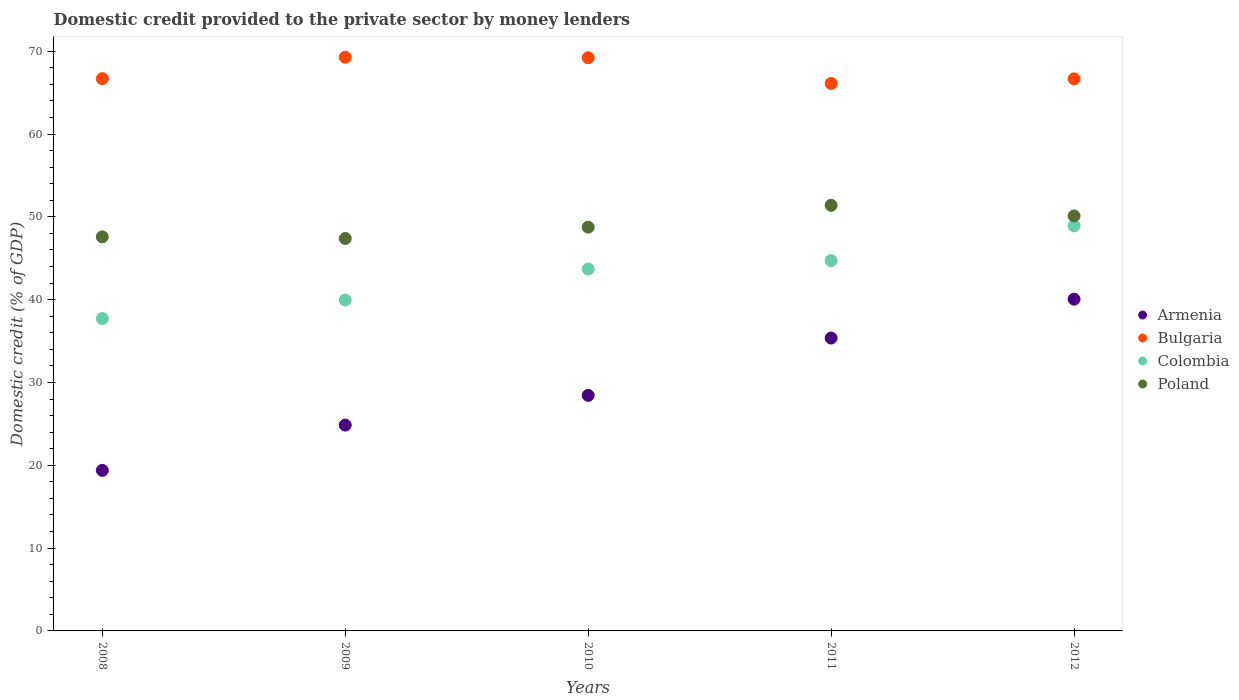How many different coloured dotlines are there?
Your response must be concise. 4. What is the domestic credit provided to the private sector by money lenders in Armenia in 2008?
Give a very brief answer. 19.39. Across all years, what is the maximum domestic credit provided to the private sector by money lenders in Bulgaria?
Your answer should be very brief. 69.28. Across all years, what is the minimum domestic credit provided to the private sector by money lenders in Colombia?
Ensure brevity in your answer.  37.72. What is the total domestic credit provided to the private sector by money lenders in Colombia in the graph?
Provide a succinct answer. 215.03. What is the difference between the domestic credit provided to the private sector by money lenders in Bulgaria in 2008 and that in 2010?
Keep it short and to the point. -2.53. What is the difference between the domestic credit provided to the private sector by money lenders in Poland in 2009 and the domestic credit provided to the private sector by money lenders in Armenia in 2010?
Provide a short and direct response. 18.95. What is the average domestic credit provided to the private sector by money lenders in Poland per year?
Ensure brevity in your answer.  49.05. In the year 2011, what is the difference between the domestic credit provided to the private sector by money lenders in Colombia and domestic credit provided to the private sector by money lenders in Bulgaria?
Keep it short and to the point. -21.4. In how many years, is the domestic credit provided to the private sector by money lenders in Poland greater than 42 %?
Make the answer very short. 5. What is the ratio of the domestic credit provided to the private sector by money lenders in Armenia in 2009 to that in 2011?
Keep it short and to the point. 0.7. Is the difference between the domestic credit provided to the private sector by money lenders in Colombia in 2010 and 2011 greater than the difference between the domestic credit provided to the private sector by money lenders in Bulgaria in 2010 and 2011?
Provide a short and direct response. No. What is the difference between the highest and the second highest domestic credit provided to the private sector by money lenders in Armenia?
Provide a short and direct response. 4.69. What is the difference between the highest and the lowest domestic credit provided to the private sector by money lenders in Poland?
Provide a succinct answer. 4.01. In how many years, is the domestic credit provided to the private sector by money lenders in Bulgaria greater than the average domestic credit provided to the private sector by money lenders in Bulgaria taken over all years?
Provide a short and direct response. 2. Is the domestic credit provided to the private sector by money lenders in Bulgaria strictly greater than the domestic credit provided to the private sector by money lenders in Armenia over the years?
Provide a short and direct response. Yes. Is the domestic credit provided to the private sector by money lenders in Poland strictly less than the domestic credit provided to the private sector by money lenders in Bulgaria over the years?
Your answer should be very brief. Yes. How many years are there in the graph?
Your answer should be very brief. 5. Are the values on the major ticks of Y-axis written in scientific E-notation?
Give a very brief answer. No. Does the graph contain any zero values?
Give a very brief answer. No. Where does the legend appear in the graph?
Make the answer very short. Center right. How are the legend labels stacked?
Your answer should be compact. Vertical. What is the title of the graph?
Provide a short and direct response. Domestic credit provided to the private sector by money lenders. Does "Turkey" appear as one of the legend labels in the graph?
Make the answer very short. No. What is the label or title of the X-axis?
Your response must be concise. Years. What is the label or title of the Y-axis?
Offer a very short reply. Domestic credit (% of GDP). What is the Domestic credit (% of GDP) in Armenia in 2008?
Your response must be concise. 19.39. What is the Domestic credit (% of GDP) in Bulgaria in 2008?
Your answer should be compact. 66.69. What is the Domestic credit (% of GDP) of Colombia in 2008?
Provide a succinct answer. 37.72. What is the Domestic credit (% of GDP) of Poland in 2008?
Offer a terse response. 47.59. What is the Domestic credit (% of GDP) in Armenia in 2009?
Make the answer very short. 24.85. What is the Domestic credit (% of GDP) in Bulgaria in 2009?
Keep it short and to the point. 69.28. What is the Domestic credit (% of GDP) in Colombia in 2009?
Your answer should be very brief. 39.96. What is the Domestic credit (% of GDP) in Poland in 2009?
Give a very brief answer. 47.39. What is the Domestic credit (% of GDP) of Armenia in 2010?
Your answer should be very brief. 28.45. What is the Domestic credit (% of GDP) in Bulgaria in 2010?
Ensure brevity in your answer.  69.23. What is the Domestic credit (% of GDP) of Colombia in 2010?
Offer a terse response. 43.7. What is the Domestic credit (% of GDP) in Poland in 2010?
Keep it short and to the point. 48.76. What is the Domestic credit (% of GDP) in Armenia in 2011?
Give a very brief answer. 35.37. What is the Domestic credit (% of GDP) of Bulgaria in 2011?
Ensure brevity in your answer.  66.12. What is the Domestic credit (% of GDP) of Colombia in 2011?
Your response must be concise. 44.72. What is the Domestic credit (% of GDP) in Poland in 2011?
Make the answer very short. 51.4. What is the Domestic credit (% of GDP) of Armenia in 2012?
Ensure brevity in your answer.  40.06. What is the Domestic credit (% of GDP) of Bulgaria in 2012?
Offer a terse response. 66.67. What is the Domestic credit (% of GDP) in Colombia in 2012?
Keep it short and to the point. 48.92. What is the Domestic credit (% of GDP) of Poland in 2012?
Your answer should be compact. 50.12. Across all years, what is the maximum Domestic credit (% of GDP) of Armenia?
Offer a terse response. 40.06. Across all years, what is the maximum Domestic credit (% of GDP) of Bulgaria?
Offer a terse response. 69.28. Across all years, what is the maximum Domestic credit (% of GDP) in Colombia?
Keep it short and to the point. 48.92. Across all years, what is the maximum Domestic credit (% of GDP) of Poland?
Offer a terse response. 51.4. Across all years, what is the minimum Domestic credit (% of GDP) in Armenia?
Your response must be concise. 19.39. Across all years, what is the minimum Domestic credit (% of GDP) in Bulgaria?
Ensure brevity in your answer.  66.12. Across all years, what is the minimum Domestic credit (% of GDP) in Colombia?
Offer a terse response. 37.72. Across all years, what is the minimum Domestic credit (% of GDP) of Poland?
Make the answer very short. 47.39. What is the total Domestic credit (% of GDP) of Armenia in the graph?
Ensure brevity in your answer.  148.11. What is the total Domestic credit (% of GDP) of Bulgaria in the graph?
Make the answer very short. 337.98. What is the total Domestic credit (% of GDP) in Colombia in the graph?
Provide a short and direct response. 215.03. What is the total Domestic credit (% of GDP) in Poland in the graph?
Provide a short and direct response. 245.25. What is the difference between the Domestic credit (% of GDP) in Armenia in 2008 and that in 2009?
Make the answer very short. -5.47. What is the difference between the Domestic credit (% of GDP) of Bulgaria in 2008 and that in 2009?
Make the answer very short. -2.58. What is the difference between the Domestic credit (% of GDP) of Colombia in 2008 and that in 2009?
Keep it short and to the point. -2.24. What is the difference between the Domestic credit (% of GDP) of Poland in 2008 and that in 2009?
Give a very brief answer. 0.2. What is the difference between the Domestic credit (% of GDP) in Armenia in 2008 and that in 2010?
Ensure brevity in your answer.  -9.06. What is the difference between the Domestic credit (% of GDP) in Bulgaria in 2008 and that in 2010?
Ensure brevity in your answer.  -2.53. What is the difference between the Domestic credit (% of GDP) of Colombia in 2008 and that in 2010?
Provide a succinct answer. -5.98. What is the difference between the Domestic credit (% of GDP) of Poland in 2008 and that in 2010?
Give a very brief answer. -1.17. What is the difference between the Domestic credit (% of GDP) of Armenia in 2008 and that in 2011?
Your answer should be very brief. -15.98. What is the difference between the Domestic credit (% of GDP) of Bulgaria in 2008 and that in 2011?
Make the answer very short. 0.58. What is the difference between the Domestic credit (% of GDP) in Colombia in 2008 and that in 2011?
Give a very brief answer. -7. What is the difference between the Domestic credit (% of GDP) in Poland in 2008 and that in 2011?
Offer a very short reply. -3.81. What is the difference between the Domestic credit (% of GDP) in Armenia in 2008 and that in 2012?
Offer a very short reply. -20.67. What is the difference between the Domestic credit (% of GDP) of Bulgaria in 2008 and that in 2012?
Give a very brief answer. 0.02. What is the difference between the Domestic credit (% of GDP) in Colombia in 2008 and that in 2012?
Your answer should be very brief. -11.2. What is the difference between the Domestic credit (% of GDP) of Poland in 2008 and that in 2012?
Provide a short and direct response. -2.53. What is the difference between the Domestic credit (% of GDP) of Armenia in 2009 and that in 2010?
Offer a very short reply. -3.59. What is the difference between the Domestic credit (% of GDP) in Bulgaria in 2009 and that in 2010?
Provide a succinct answer. 0.05. What is the difference between the Domestic credit (% of GDP) of Colombia in 2009 and that in 2010?
Ensure brevity in your answer.  -3.74. What is the difference between the Domestic credit (% of GDP) of Poland in 2009 and that in 2010?
Provide a short and direct response. -1.37. What is the difference between the Domestic credit (% of GDP) in Armenia in 2009 and that in 2011?
Make the answer very short. -10.51. What is the difference between the Domestic credit (% of GDP) of Bulgaria in 2009 and that in 2011?
Provide a succinct answer. 3.16. What is the difference between the Domestic credit (% of GDP) in Colombia in 2009 and that in 2011?
Your answer should be very brief. -4.75. What is the difference between the Domestic credit (% of GDP) in Poland in 2009 and that in 2011?
Your answer should be very brief. -4.01. What is the difference between the Domestic credit (% of GDP) of Armenia in 2009 and that in 2012?
Give a very brief answer. -15.21. What is the difference between the Domestic credit (% of GDP) of Bulgaria in 2009 and that in 2012?
Ensure brevity in your answer.  2.61. What is the difference between the Domestic credit (% of GDP) in Colombia in 2009 and that in 2012?
Your answer should be compact. -8.96. What is the difference between the Domestic credit (% of GDP) in Poland in 2009 and that in 2012?
Your answer should be compact. -2.73. What is the difference between the Domestic credit (% of GDP) of Armenia in 2010 and that in 2011?
Give a very brief answer. -6.92. What is the difference between the Domestic credit (% of GDP) of Bulgaria in 2010 and that in 2011?
Provide a short and direct response. 3.11. What is the difference between the Domestic credit (% of GDP) in Colombia in 2010 and that in 2011?
Provide a short and direct response. -1.02. What is the difference between the Domestic credit (% of GDP) in Poland in 2010 and that in 2011?
Your answer should be very brief. -2.64. What is the difference between the Domestic credit (% of GDP) in Armenia in 2010 and that in 2012?
Your response must be concise. -11.61. What is the difference between the Domestic credit (% of GDP) of Bulgaria in 2010 and that in 2012?
Offer a very short reply. 2.56. What is the difference between the Domestic credit (% of GDP) in Colombia in 2010 and that in 2012?
Make the answer very short. -5.22. What is the difference between the Domestic credit (% of GDP) of Poland in 2010 and that in 2012?
Your response must be concise. -1.36. What is the difference between the Domestic credit (% of GDP) in Armenia in 2011 and that in 2012?
Your answer should be very brief. -4.69. What is the difference between the Domestic credit (% of GDP) of Bulgaria in 2011 and that in 2012?
Ensure brevity in your answer.  -0.55. What is the difference between the Domestic credit (% of GDP) of Colombia in 2011 and that in 2012?
Offer a very short reply. -4.2. What is the difference between the Domestic credit (% of GDP) in Poland in 2011 and that in 2012?
Offer a very short reply. 1.28. What is the difference between the Domestic credit (% of GDP) in Armenia in 2008 and the Domestic credit (% of GDP) in Bulgaria in 2009?
Make the answer very short. -49.89. What is the difference between the Domestic credit (% of GDP) in Armenia in 2008 and the Domestic credit (% of GDP) in Colombia in 2009?
Ensure brevity in your answer.  -20.58. What is the difference between the Domestic credit (% of GDP) of Armenia in 2008 and the Domestic credit (% of GDP) of Poland in 2009?
Provide a short and direct response. -28. What is the difference between the Domestic credit (% of GDP) in Bulgaria in 2008 and the Domestic credit (% of GDP) in Colombia in 2009?
Make the answer very short. 26.73. What is the difference between the Domestic credit (% of GDP) in Bulgaria in 2008 and the Domestic credit (% of GDP) in Poland in 2009?
Ensure brevity in your answer.  19.3. What is the difference between the Domestic credit (% of GDP) of Colombia in 2008 and the Domestic credit (% of GDP) of Poland in 2009?
Make the answer very short. -9.67. What is the difference between the Domestic credit (% of GDP) in Armenia in 2008 and the Domestic credit (% of GDP) in Bulgaria in 2010?
Ensure brevity in your answer.  -49.84. What is the difference between the Domestic credit (% of GDP) of Armenia in 2008 and the Domestic credit (% of GDP) of Colombia in 2010?
Offer a very short reply. -24.32. What is the difference between the Domestic credit (% of GDP) in Armenia in 2008 and the Domestic credit (% of GDP) in Poland in 2010?
Give a very brief answer. -29.37. What is the difference between the Domestic credit (% of GDP) in Bulgaria in 2008 and the Domestic credit (% of GDP) in Colombia in 2010?
Provide a succinct answer. 22.99. What is the difference between the Domestic credit (% of GDP) in Bulgaria in 2008 and the Domestic credit (% of GDP) in Poland in 2010?
Give a very brief answer. 17.94. What is the difference between the Domestic credit (% of GDP) of Colombia in 2008 and the Domestic credit (% of GDP) of Poland in 2010?
Your answer should be very brief. -11.04. What is the difference between the Domestic credit (% of GDP) in Armenia in 2008 and the Domestic credit (% of GDP) in Bulgaria in 2011?
Offer a very short reply. -46.73. What is the difference between the Domestic credit (% of GDP) in Armenia in 2008 and the Domestic credit (% of GDP) in Colombia in 2011?
Your answer should be compact. -25.33. What is the difference between the Domestic credit (% of GDP) in Armenia in 2008 and the Domestic credit (% of GDP) in Poland in 2011?
Your answer should be very brief. -32.01. What is the difference between the Domestic credit (% of GDP) of Bulgaria in 2008 and the Domestic credit (% of GDP) of Colombia in 2011?
Your response must be concise. 21.98. What is the difference between the Domestic credit (% of GDP) in Bulgaria in 2008 and the Domestic credit (% of GDP) in Poland in 2011?
Offer a terse response. 15.3. What is the difference between the Domestic credit (% of GDP) of Colombia in 2008 and the Domestic credit (% of GDP) of Poland in 2011?
Ensure brevity in your answer.  -13.68. What is the difference between the Domestic credit (% of GDP) in Armenia in 2008 and the Domestic credit (% of GDP) in Bulgaria in 2012?
Your response must be concise. -47.28. What is the difference between the Domestic credit (% of GDP) in Armenia in 2008 and the Domestic credit (% of GDP) in Colombia in 2012?
Give a very brief answer. -29.54. What is the difference between the Domestic credit (% of GDP) in Armenia in 2008 and the Domestic credit (% of GDP) in Poland in 2012?
Provide a short and direct response. -30.73. What is the difference between the Domestic credit (% of GDP) in Bulgaria in 2008 and the Domestic credit (% of GDP) in Colombia in 2012?
Your response must be concise. 17.77. What is the difference between the Domestic credit (% of GDP) in Bulgaria in 2008 and the Domestic credit (% of GDP) in Poland in 2012?
Offer a very short reply. 16.58. What is the difference between the Domestic credit (% of GDP) in Colombia in 2008 and the Domestic credit (% of GDP) in Poland in 2012?
Your response must be concise. -12.4. What is the difference between the Domestic credit (% of GDP) in Armenia in 2009 and the Domestic credit (% of GDP) in Bulgaria in 2010?
Give a very brief answer. -44.37. What is the difference between the Domestic credit (% of GDP) of Armenia in 2009 and the Domestic credit (% of GDP) of Colombia in 2010?
Your answer should be compact. -18.85. What is the difference between the Domestic credit (% of GDP) of Armenia in 2009 and the Domestic credit (% of GDP) of Poland in 2010?
Make the answer very short. -23.9. What is the difference between the Domestic credit (% of GDP) of Bulgaria in 2009 and the Domestic credit (% of GDP) of Colombia in 2010?
Provide a short and direct response. 25.58. What is the difference between the Domestic credit (% of GDP) in Bulgaria in 2009 and the Domestic credit (% of GDP) in Poland in 2010?
Give a very brief answer. 20.52. What is the difference between the Domestic credit (% of GDP) of Colombia in 2009 and the Domestic credit (% of GDP) of Poland in 2010?
Keep it short and to the point. -8.79. What is the difference between the Domestic credit (% of GDP) of Armenia in 2009 and the Domestic credit (% of GDP) of Bulgaria in 2011?
Keep it short and to the point. -41.26. What is the difference between the Domestic credit (% of GDP) of Armenia in 2009 and the Domestic credit (% of GDP) of Colombia in 2011?
Offer a very short reply. -19.86. What is the difference between the Domestic credit (% of GDP) of Armenia in 2009 and the Domestic credit (% of GDP) of Poland in 2011?
Provide a succinct answer. -26.54. What is the difference between the Domestic credit (% of GDP) of Bulgaria in 2009 and the Domestic credit (% of GDP) of Colombia in 2011?
Give a very brief answer. 24.56. What is the difference between the Domestic credit (% of GDP) of Bulgaria in 2009 and the Domestic credit (% of GDP) of Poland in 2011?
Keep it short and to the point. 17.88. What is the difference between the Domestic credit (% of GDP) in Colombia in 2009 and the Domestic credit (% of GDP) in Poland in 2011?
Give a very brief answer. -11.43. What is the difference between the Domestic credit (% of GDP) in Armenia in 2009 and the Domestic credit (% of GDP) in Bulgaria in 2012?
Your answer should be compact. -41.82. What is the difference between the Domestic credit (% of GDP) in Armenia in 2009 and the Domestic credit (% of GDP) in Colombia in 2012?
Your response must be concise. -24.07. What is the difference between the Domestic credit (% of GDP) of Armenia in 2009 and the Domestic credit (% of GDP) of Poland in 2012?
Your answer should be compact. -25.26. What is the difference between the Domestic credit (% of GDP) in Bulgaria in 2009 and the Domestic credit (% of GDP) in Colombia in 2012?
Keep it short and to the point. 20.36. What is the difference between the Domestic credit (% of GDP) of Bulgaria in 2009 and the Domestic credit (% of GDP) of Poland in 2012?
Ensure brevity in your answer.  19.16. What is the difference between the Domestic credit (% of GDP) in Colombia in 2009 and the Domestic credit (% of GDP) in Poland in 2012?
Your answer should be compact. -10.15. What is the difference between the Domestic credit (% of GDP) in Armenia in 2010 and the Domestic credit (% of GDP) in Bulgaria in 2011?
Your answer should be very brief. -37.67. What is the difference between the Domestic credit (% of GDP) of Armenia in 2010 and the Domestic credit (% of GDP) of Colombia in 2011?
Offer a terse response. -16.27. What is the difference between the Domestic credit (% of GDP) in Armenia in 2010 and the Domestic credit (% of GDP) in Poland in 2011?
Provide a short and direct response. -22.95. What is the difference between the Domestic credit (% of GDP) in Bulgaria in 2010 and the Domestic credit (% of GDP) in Colombia in 2011?
Offer a very short reply. 24.51. What is the difference between the Domestic credit (% of GDP) in Bulgaria in 2010 and the Domestic credit (% of GDP) in Poland in 2011?
Your response must be concise. 17.83. What is the difference between the Domestic credit (% of GDP) in Colombia in 2010 and the Domestic credit (% of GDP) in Poland in 2011?
Your answer should be very brief. -7.69. What is the difference between the Domestic credit (% of GDP) of Armenia in 2010 and the Domestic credit (% of GDP) of Bulgaria in 2012?
Offer a terse response. -38.22. What is the difference between the Domestic credit (% of GDP) of Armenia in 2010 and the Domestic credit (% of GDP) of Colombia in 2012?
Provide a succinct answer. -20.48. What is the difference between the Domestic credit (% of GDP) in Armenia in 2010 and the Domestic credit (% of GDP) in Poland in 2012?
Your answer should be compact. -21.67. What is the difference between the Domestic credit (% of GDP) of Bulgaria in 2010 and the Domestic credit (% of GDP) of Colombia in 2012?
Your answer should be very brief. 20.3. What is the difference between the Domestic credit (% of GDP) of Bulgaria in 2010 and the Domestic credit (% of GDP) of Poland in 2012?
Make the answer very short. 19.11. What is the difference between the Domestic credit (% of GDP) of Colombia in 2010 and the Domestic credit (% of GDP) of Poland in 2012?
Ensure brevity in your answer.  -6.41. What is the difference between the Domestic credit (% of GDP) of Armenia in 2011 and the Domestic credit (% of GDP) of Bulgaria in 2012?
Offer a very short reply. -31.3. What is the difference between the Domestic credit (% of GDP) in Armenia in 2011 and the Domestic credit (% of GDP) in Colombia in 2012?
Your answer should be compact. -13.56. What is the difference between the Domestic credit (% of GDP) of Armenia in 2011 and the Domestic credit (% of GDP) of Poland in 2012?
Your answer should be compact. -14.75. What is the difference between the Domestic credit (% of GDP) of Bulgaria in 2011 and the Domestic credit (% of GDP) of Colombia in 2012?
Provide a short and direct response. 17.19. What is the difference between the Domestic credit (% of GDP) of Bulgaria in 2011 and the Domestic credit (% of GDP) of Poland in 2012?
Offer a terse response. 16. What is the difference between the Domestic credit (% of GDP) of Colombia in 2011 and the Domestic credit (% of GDP) of Poland in 2012?
Offer a very short reply. -5.4. What is the average Domestic credit (% of GDP) of Armenia per year?
Keep it short and to the point. 29.62. What is the average Domestic credit (% of GDP) in Bulgaria per year?
Ensure brevity in your answer.  67.6. What is the average Domestic credit (% of GDP) of Colombia per year?
Give a very brief answer. 43.01. What is the average Domestic credit (% of GDP) in Poland per year?
Ensure brevity in your answer.  49.05. In the year 2008, what is the difference between the Domestic credit (% of GDP) of Armenia and Domestic credit (% of GDP) of Bulgaria?
Offer a very short reply. -47.31. In the year 2008, what is the difference between the Domestic credit (% of GDP) in Armenia and Domestic credit (% of GDP) in Colombia?
Your answer should be very brief. -18.33. In the year 2008, what is the difference between the Domestic credit (% of GDP) in Armenia and Domestic credit (% of GDP) in Poland?
Make the answer very short. -28.2. In the year 2008, what is the difference between the Domestic credit (% of GDP) of Bulgaria and Domestic credit (% of GDP) of Colombia?
Your response must be concise. 28.97. In the year 2008, what is the difference between the Domestic credit (% of GDP) in Bulgaria and Domestic credit (% of GDP) in Poland?
Provide a succinct answer. 19.11. In the year 2008, what is the difference between the Domestic credit (% of GDP) of Colombia and Domestic credit (% of GDP) of Poland?
Offer a very short reply. -9.87. In the year 2009, what is the difference between the Domestic credit (% of GDP) of Armenia and Domestic credit (% of GDP) of Bulgaria?
Ensure brevity in your answer.  -44.42. In the year 2009, what is the difference between the Domestic credit (% of GDP) in Armenia and Domestic credit (% of GDP) in Colombia?
Offer a terse response. -15.11. In the year 2009, what is the difference between the Domestic credit (% of GDP) of Armenia and Domestic credit (% of GDP) of Poland?
Offer a very short reply. -22.54. In the year 2009, what is the difference between the Domestic credit (% of GDP) of Bulgaria and Domestic credit (% of GDP) of Colombia?
Ensure brevity in your answer.  29.31. In the year 2009, what is the difference between the Domestic credit (% of GDP) of Bulgaria and Domestic credit (% of GDP) of Poland?
Ensure brevity in your answer.  21.89. In the year 2009, what is the difference between the Domestic credit (% of GDP) in Colombia and Domestic credit (% of GDP) in Poland?
Ensure brevity in your answer.  -7.43. In the year 2010, what is the difference between the Domestic credit (% of GDP) of Armenia and Domestic credit (% of GDP) of Bulgaria?
Ensure brevity in your answer.  -40.78. In the year 2010, what is the difference between the Domestic credit (% of GDP) of Armenia and Domestic credit (% of GDP) of Colombia?
Ensure brevity in your answer.  -15.26. In the year 2010, what is the difference between the Domestic credit (% of GDP) of Armenia and Domestic credit (% of GDP) of Poland?
Offer a very short reply. -20.31. In the year 2010, what is the difference between the Domestic credit (% of GDP) of Bulgaria and Domestic credit (% of GDP) of Colombia?
Your answer should be compact. 25.52. In the year 2010, what is the difference between the Domestic credit (% of GDP) of Bulgaria and Domestic credit (% of GDP) of Poland?
Offer a terse response. 20.47. In the year 2010, what is the difference between the Domestic credit (% of GDP) in Colombia and Domestic credit (% of GDP) in Poland?
Your answer should be very brief. -5.05. In the year 2011, what is the difference between the Domestic credit (% of GDP) of Armenia and Domestic credit (% of GDP) of Bulgaria?
Your response must be concise. -30.75. In the year 2011, what is the difference between the Domestic credit (% of GDP) of Armenia and Domestic credit (% of GDP) of Colombia?
Provide a succinct answer. -9.35. In the year 2011, what is the difference between the Domestic credit (% of GDP) in Armenia and Domestic credit (% of GDP) in Poland?
Offer a very short reply. -16.03. In the year 2011, what is the difference between the Domestic credit (% of GDP) of Bulgaria and Domestic credit (% of GDP) of Colombia?
Make the answer very short. 21.4. In the year 2011, what is the difference between the Domestic credit (% of GDP) of Bulgaria and Domestic credit (% of GDP) of Poland?
Your response must be concise. 14.72. In the year 2011, what is the difference between the Domestic credit (% of GDP) in Colombia and Domestic credit (% of GDP) in Poland?
Give a very brief answer. -6.68. In the year 2012, what is the difference between the Domestic credit (% of GDP) of Armenia and Domestic credit (% of GDP) of Bulgaria?
Offer a very short reply. -26.61. In the year 2012, what is the difference between the Domestic credit (% of GDP) of Armenia and Domestic credit (% of GDP) of Colombia?
Offer a terse response. -8.86. In the year 2012, what is the difference between the Domestic credit (% of GDP) of Armenia and Domestic credit (% of GDP) of Poland?
Give a very brief answer. -10.06. In the year 2012, what is the difference between the Domestic credit (% of GDP) in Bulgaria and Domestic credit (% of GDP) in Colombia?
Your answer should be very brief. 17.75. In the year 2012, what is the difference between the Domestic credit (% of GDP) of Bulgaria and Domestic credit (% of GDP) of Poland?
Ensure brevity in your answer.  16.55. In the year 2012, what is the difference between the Domestic credit (% of GDP) of Colombia and Domestic credit (% of GDP) of Poland?
Keep it short and to the point. -1.19. What is the ratio of the Domestic credit (% of GDP) in Armenia in 2008 to that in 2009?
Provide a short and direct response. 0.78. What is the ratio of the Domestic credit (% of GDP) in Bulgaria in 2008 to that in 2009?
Provide a succinct answer. 0.96. What is the ratio of the Domestic credit (% of GDP) in Colombia in 2008 to that in 2009?
Make the answer very short. 0.94. What is the ratio of the Domestic credit (% of GDP) of Poland in 2008 to that in 2009?
Provide a succinct answer. 1. What is the ratio of the Domestic credit (% of GDP) of Armenia in 2008 to that in 2010?
Provide a short and direct response. 0.68. What is the ratio of the Domestic credit (% of GDP) in Bulgaria in 2008 to that in 2010?
Ensure brevity in your answer.  0.96. What is the ratio of the Domestic credit (% of GDP) in Colombia in 2008 to that in 2010?
Offer a very short reply. 0.86. What is the ratio of the Domestic credit (% of GDP) of Poland in 2008 to that in 2010?
Your answer should be very brief. 0.98. What is the ratio of the Domestic credit (% of GDP) in Armenia in 2008 to that in 2011?
Your response must be concise. 0.55. What is the ratio of the Domestic credit (% of GDP) of Bulgaria in 2008 to that in 2011?
Your response must be concise. 1.01. What is the ratio of the Domestic credit (% of GDP) of Colombia in 2008 to that in 2011?
Your answer should be very brief. 0.84. What is the ratio of the Domestic credit (% of GDP) in Poland in 2008 to that in 2011?
Your answer should be compact. 0.93. What is the ratio of the Domestic credit (% of GDP) in Armenia in 2008 to that in 2012?
Ensure brevity in your answer.  0.48. What is the ratio of the Domestic credit (% of GDP) in Colombia in 2008 to that in 2012?
Offer a very short reply. 0.77. What is the ratio of the Domestic credit (% of GDP) of Poland in 2008 to that in 2012?
Your answer should be compact. 0.95. What is the ratio of the Domestic credit (% of GDP) of Armenia in 2009 to that in 2010?
Give a very brief answer. 0.87. What is the ratio of the Domestic credit (% of GDP) in Colombia in 2009 to that in 2010?
Ensure brevity in your answer.  0.91. What is the ratio of the Domestic credit (% of GDP) in Armenia in 2009 to that in 2011?
Your response must be concise. 0.7. What is the ratio of the Domestic credit (% of GDP) in Bulgaria in 2009 to that in 2011?
Your answer should be very brief. 1.05. What is the ratio of the Domestic credit (% of GDP) in Colombia in 2009 to that in 2011?
Provide a succinct answer. 0.89. What is the ratio of the Domestic credit (% of GDP) in Poland in 2009 to that in 2011?
Your answer should be very brief. 0.92. What is the ratio of the Domestic credit (% of GDP) of Armenia in 2009 to that in 2012?
Provide a short and direct response. 0.62. What is the ratio of the Domestic credit (% of GDP) in Bulgaria in 2009 to that in 2012?
Your answer should be very brief. 1.04. What is the ratio of the Domestic credit (% of GDP) in Colombia in 2009 to that in 2012?
Give a very brief answer. 0.82. What is the ratio of the Domestic credit (% of GDP) of Poland in 2009 to that in 2012?
Ensure brevity in your answer.  0.95. What is the ratio of the Domestic credit (% of GDP) of Armenia in 2010 to that in 2011?
Offer a terse response. 0.8. What is the ratio of the Domestic credit (% of GDP) in Bulgaria in 2010 to that in 2011?
Provide a short and direct response. 1.05. What is the ratio of the Domestic credit (% of GDP) of Colombia in 2010 to that in 2011?
Offer a terse response. 0.98. What is the ratio of the Domestic credit (% of GDP) in Poland in 2010 to that in 2011?
Ensure brevity in your answer.  0.95. What is the ratio of the Domestic credit (% of GDP) of Armenia in 2010 to that in 2012?
Your answer should be compact. 0.71. What is the ratio of the Domestic credit (% of GDP) in Bulgaria in 2010 to that in 2012?
Your response must be concise. 1.04. What is the ratio of the Domestic credit (% of GDP) of Colombia in 2010 to that in 2012?
Offer a terse response. 0.89. What is the ratio of the Domestic credit (% of GDP) in Poland in 2010 to that in 2012?
Your answer should be compact. 0.97. What is the ratio of the Domestic credit (% of GDP) of Armenia in 2011 to that in 2012?
Make the answer very short. 0.88. What is the ratio of the Domestic credit (% of GDP) in Bulgaria in 2011 to that in 2012?
Keep it short and to the point. 0.99. What is the ratio of the Domestic credit (% of GDP) in Colombia in 2011 to that in 2012?
Your answer should be compact. 0.91. What is the ratio of the Domestic credit (% of GDP) of Poland in 2011 to that in 2012?
Your answer should be compact. 1.03. What is the difference between the highest and the second highest Domestic credit (% of GDP) in Armenia?
Keep it short and to the point. 4.69. What is the difference between the highest and the second highest Domestic credit (% of GDP) of Bulgaria?
Ensure brevity in your answer.  0.05. What is the difference between the highest and the second highest Domestic credit (% of GDP) of Colombia?
Provide a succinct answer. 4.2. What is the difference between the highest and the second highest Domestic credit (% of GDP) of Poland?
Keep it short and to the point. 1.28. What is the difference between the highest and the lowest Domestic credit (% of GDP) in Armenia?
Your answer should be compact. 20.67. What is the difference between the highest and the lowest Domestic credit (% of GDP) of Bulgaria?
Provide a short and direct response. 3.16. What is the difference between the highest and the lowest Domestic credit (% of GDP) in Colombia?
Keep it short and to the point. 11.2. What is the difference between the highest and the lowest Domestic credit (% of GDP) in Poland?
Your response must be concise. 4.01. 